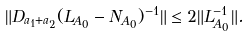<formula> <loc_0><loc_0><loc_500><loc_500>\| D _ { a _ { 1 } + a _ { 2 } } ( L _ { A _ { 0 } } - N _ { A _ { 0 } } ) ^ { - 1 } \| \leq 2 \| L _ { A _ { 0 } } ^ { - 1 } \| .</formula> 